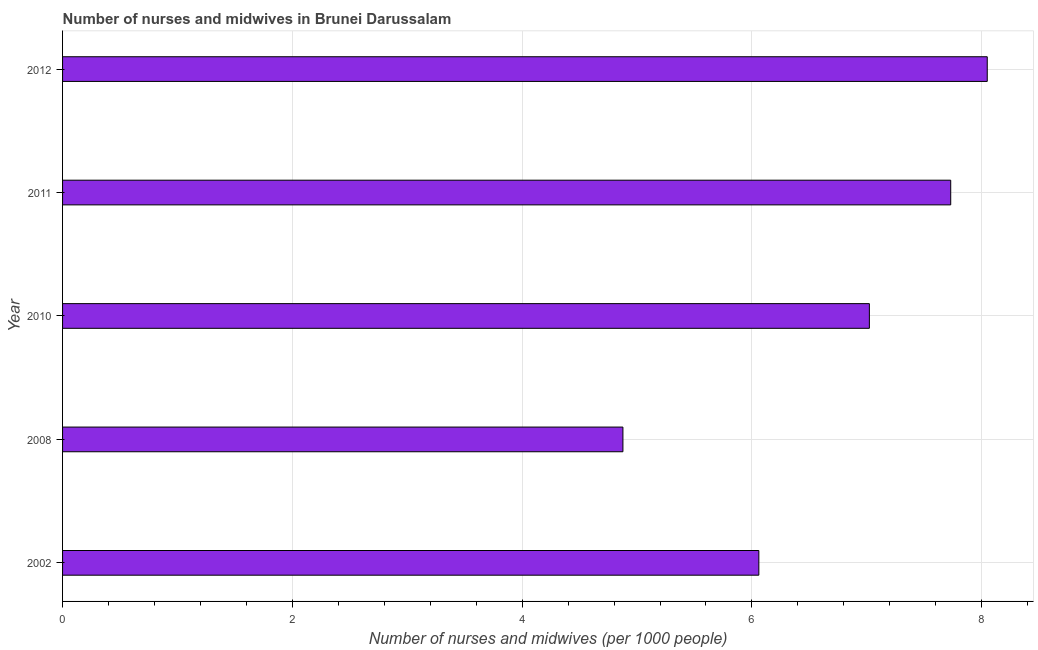Does the graph contain any zero values?
Your response must be concise. No. What is the title of the graph?
Offer a very short reply. Number of nurses and midwives in Brunei Darussalam. What is the label or title of the X-axis?
Make the answer very short. Number of nurses and midwives (per 1000 people). What is the label or title of the Y-axis?
Ensure brevity in your answer.  Year. What is the number of nurses and midwives in 2002?
Your response must be concise. 6.06. Across all years, what is the maximum number of nurses and midwives?
Provide a succinct answer. 8.05. Across all years, what is the minimum number of nurses and midwives?
Offer a very short reply. 4.88. In which year was the number of nurses and midwives minimum?
Ensure brevity in your answer.  2008. What is the sum of the number of nurses and midwives?
Offer a terse response. 33.74. What is the difference between the number of nurses and midwives in 2002 and 2012?
Offer a terse response. -1.99. What is the average number of nurses and midwives per year?
Your answer should be very brief. 6.75. What is the median number of nurses and midwives?
Your answer should be very brief. 7.02. In how many years, is the number of nurses and midwives greater than 0.8 ?
Provide a short and direct response. 5. Do a majority of the years between 2011 and 2012 (inclusive) have number of nurses and midwives greater than 5.2 ?
Provide a succinct answer. Yes. What is the ratio of the number of nurses and midwives in 2008 to that in 2010?
Your answer should be very brief. 0.69. Is the number of nurses and midwives in 2002 less than that in 2008?
Offer a terse response. No. Is the difference between the number of nurses and midwives in 2010 and 2011 greater than the difference between any two years?
Give a very brief answer. No. What is the difference between the highest and the second highest number of nurses and midwives?
Give a very brief answer. 0.32. Is the sum of the number of nurses and midwives in 2011 and 2012 greater than the maximum number of nurses and midwives across all years?
Your answer should be very brief. Yes. What is the difference between the highest and the lowest number of nurses and midwives?
Give a very brief answer. 3.17. How many bars are there?
Your answer should be compact. 5. How many years are there in the graph?
Your answer should be very brief. 5. Are the values on the major ticks of X-axis written in scientific E-notation?
Ensure brevity in your answer.  No. What is the Number of nurses and midwives (per 1000 people) of 2002?
Your answer should be compact. 6.06. What is the Number of nurses and midwives (per 1000 people) of 2008?
Provide a short and direct response. 4.88. What is the Number of nurses and midwives (per 1000 people) of 2010?
Your response must be concise. 7.02. What is the Number of nurses and midwives (per 1000 people) in 2011?
Ensure brevity in your answer.  7.73. What is the Number of nurses and midwives (per 1000 people) of 2012?
Give a very brief answer. 8.05. What is the difference between the Number of nurses and midwives (per 1000 people) in 2002 and 2008?
Offer a very short reply. 1.18. What is the difference between the Number of nurses and midwives (per 1000 people) in 2002 and 2010?
Your response must be concise. -0.96. What is the difference between the Number of nurses and midwives (per 1000 people) in 2002 and 2011?
Your answer should be compact. -1.67. What is the difference between the Number of nurses and midwives (per 1000 people) in 2002 and 2012?
Your answer should be compact. -1.99. What is the difference between the Number of nurses and midwives (per 1000 people) in 2008 and 2010?
Ensure brevity in your answer.  -2.15. What is the difference between the Number of nurses and midwives (per 1000 people) in 2008 and 2011?
Your response must be concise. -2.85. What is the difference between the Number of nurses and midwives (per 1000 people) in 2008 and 2012?
Provide a short and direct response. -3.17. What is the difference between the Number of nurses and midwives (per 1000 people) in 2010 and 2011?
Provide a short and direct response. -0.71. What is the difference between the Number of nurses and midwives (per 1000 people) in 2010 and 2012?
Your answer should be compact. -1.03. What is the difference between the Number of nurses and midwives (per 1000 people) in 2011 and 2012?
Your response must be concise. -0.32. What is the ratio of the Number of nurses and midwives (per 1000 people) in 2002 to that in 2008?
Offer a terse response. 1.24. What is the ratio of the Number of nurses and midwives (per 1000 people) in 2002 to that in 2010?
Offer a terse response. 0.86. What is the ratio of the Number of nurses and midwives (per 1000 people) in 2002 to that in 2011?
Keep it short and to the point. 0.78. What is the ratio of the Number of nurses and midwives (per 1000 people) in 2002 to that in 2012?
Provide a short and direct response. 0.75. What is the ratio of the Number of nurses and midwives (per 1000 people) in 2008 to that in 2010?
Keep it short and to the point. 0.69. What is the ratio of the Number of nurses and midwives (per 1000 people) in 2008 to that in 2011?
Keep it short and to the point. 0.63. What is the ratio of the Number of nurses and midwives (per 1000 people) in 2008 to that in 2012?
Your response must be concise. 0.61. What is the ratio of the Number of nurses and midwives (per 1000 people) in 2010 to that in 2011?
Provide a succinct answer. 0.91. What is the ratio of the Number of nurses and midwives (per 1000 people) in 2010 to that in 2012?
Provide a short and direct response. 0.87. What is the ratio of the Number of nurses and midwives (per 1000 people) in 2011 to that in 2012?
Keep it short and to the point. 0.96. 